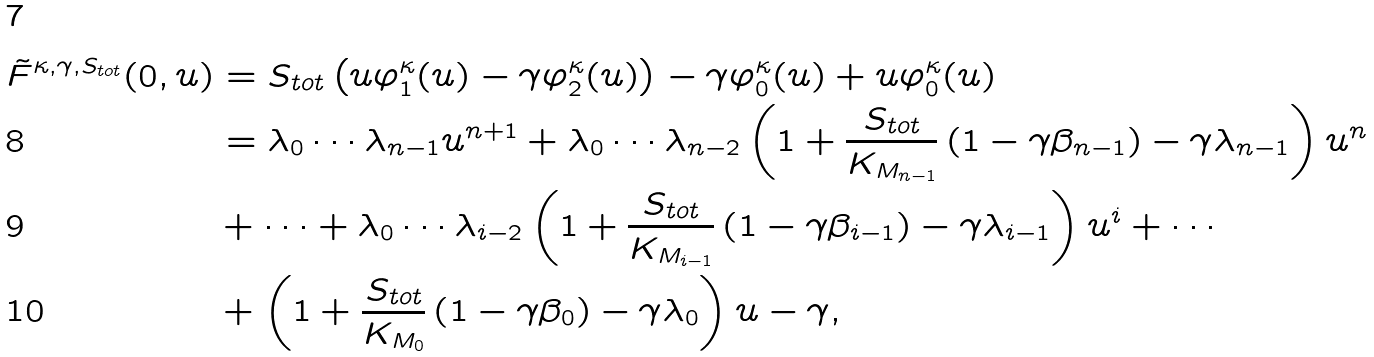<formula> <loc_0><loc_0><loc_500><loc_500>\tilde { F } ^ { \kappa , \gamma , S _ { t o t } } ( 0 , u ) & = S _ { t o t } \left ( u \varphi _ { 1 } ^ { \kappa } ( u ) - \gamma \varphi _ { 2 } ^ { \kappa } ( u ) \right ) - \gamma \varphi _ { 0 } ^ { \kappa } ( u ) + u \varphi _ { 0 } ^ { \kappa } ( u ) \\ & = \lambda _ { 0 } \cdots \lambda _ { n - 1 } u ^ { n + 1 } + \lambda _ { 0 } \cdots \lambda _ { n - 2 } \left ( 1 + \frac { S _ { t o t } } { K _ { M _ { n - 1 } } } \left ( 1 - \gamma \beta _ { n - 1 } \right ) - \gamma \lambda _ { n - 1 } \right ) u ^ { n } \\ & + \cdots + \lambda _ { 0 } \cdots \lambda _ { i - 2 } \left ( 1 + \frac { S _ { t o t } } { K _ { M _ { i - 1 } } } \left ( 1 - \gamma \beta _ { i - 1 } \right ) - \gamma \lambda _ { i - 1 } \right ) u ^ { i } + \cdots \\ & + \left ( 1 + \frac { S _ { t o t } } { K _ { M _ { 0 } } } \left ( 1 - \gamma \beta _ { 0 } \right ) - \gamma \lambda _ { 0 } \right ) u - \gamma ,</formula> 